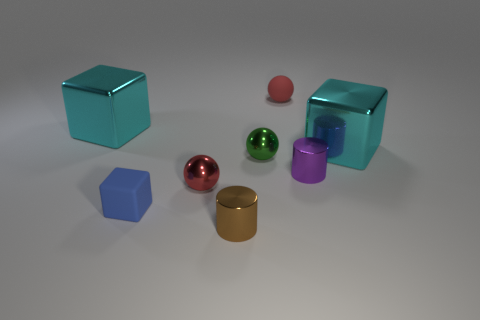Can you tell me the number of objects that have reflective surfaces? Certainly! The image depicts several objects with reflective surfaces. Upon closer inspection, it appears that all the objects have some level of reflectivity due to the way the light interacts with their surfaces. 